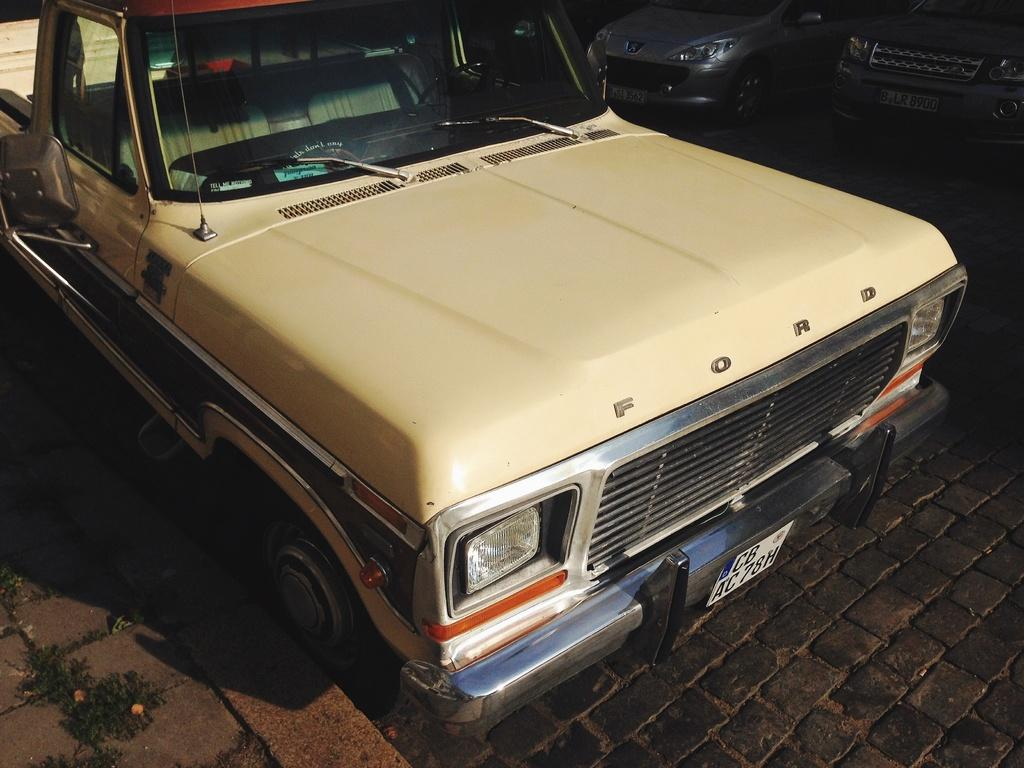What is the main subject of the picture? The main subject of the picture is a car. Are there any other cars visible in the image? Yes, there are two additional cars in the top right corner of the image, presumably in a parking area. What type of machine is the boy using to experience thrill in the image? There is no boy or machine present in the image; it only features cars. 